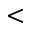Convert formula to latex. <formula><loc_0><loc_0><loc_500><loc_500><</formula> 